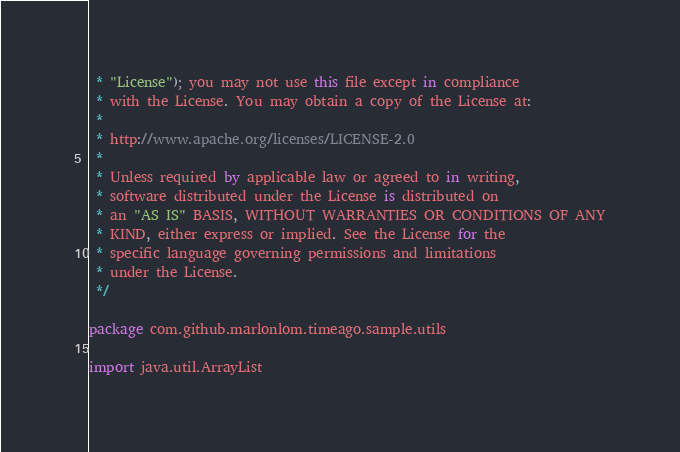<code> <loc_0><loc_0><loc_500><loc_500><_Kotlin_> * "License"); you may not use this file except in compliance
 * with the License. You may obtain a copy of the License at:
 *
 * http://www.apache.org/licenses/LICENSE-2.0
 *
 * Unless required by applicable law or agreed to in writing,
 * software distributed under the License is distributed on
 * an "AS IS" BASIS, WITHOUT WARRANTIES OR CONDITIONS OF ANY
 * KIND, either express or implied. See the License for the
 * specific language governing permissions and limitations
 * under the License.
 */

package com.github.marlonlom.timeago.sample.utils

import java.util.ArrayList</code> 